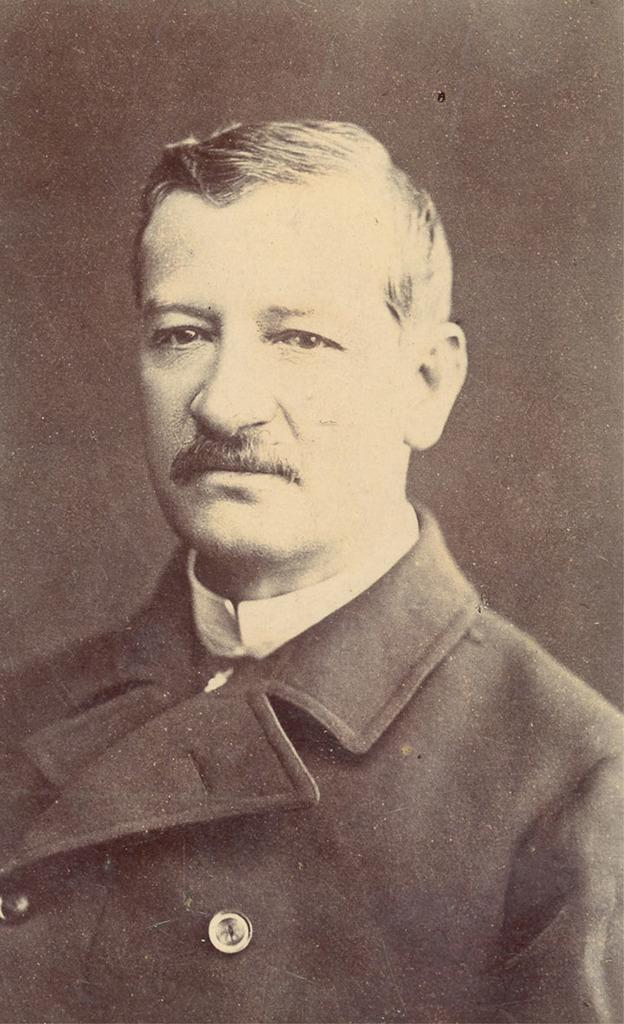What is the color scheme of the image? The image is black and white. Who is present in the image? There is a man in a suit in the image. What can be seen behind the man? The background is black and blurred. What record did the man in the suit break in the image? There is no indication in the image that the man in the suit broke any records. 